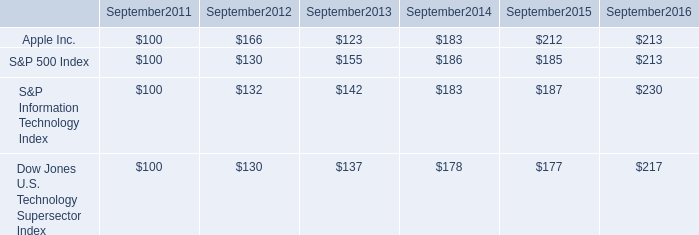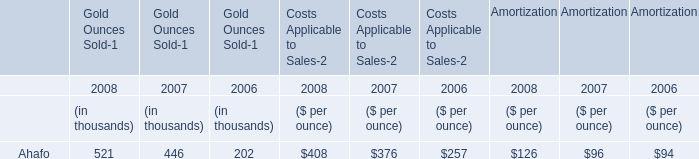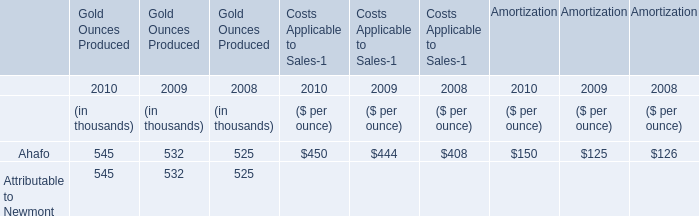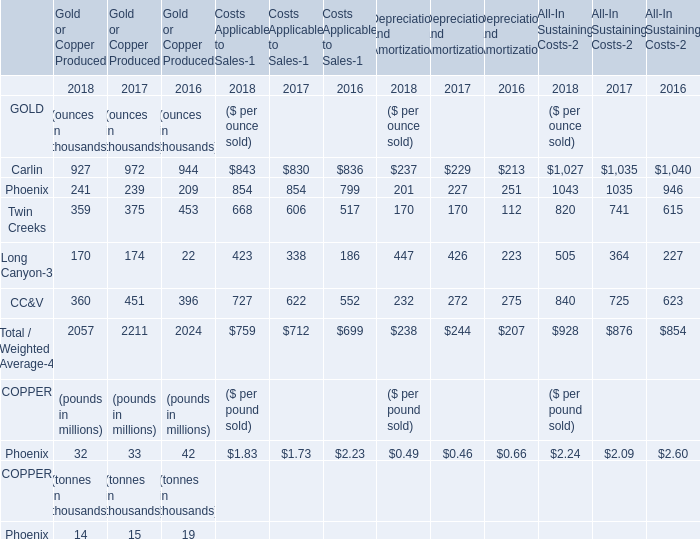what was the 1 year return of apple inc . from 2013 to 2014? 
Computations: ((183 - 123) / 123)
Answer: 0.4878. 